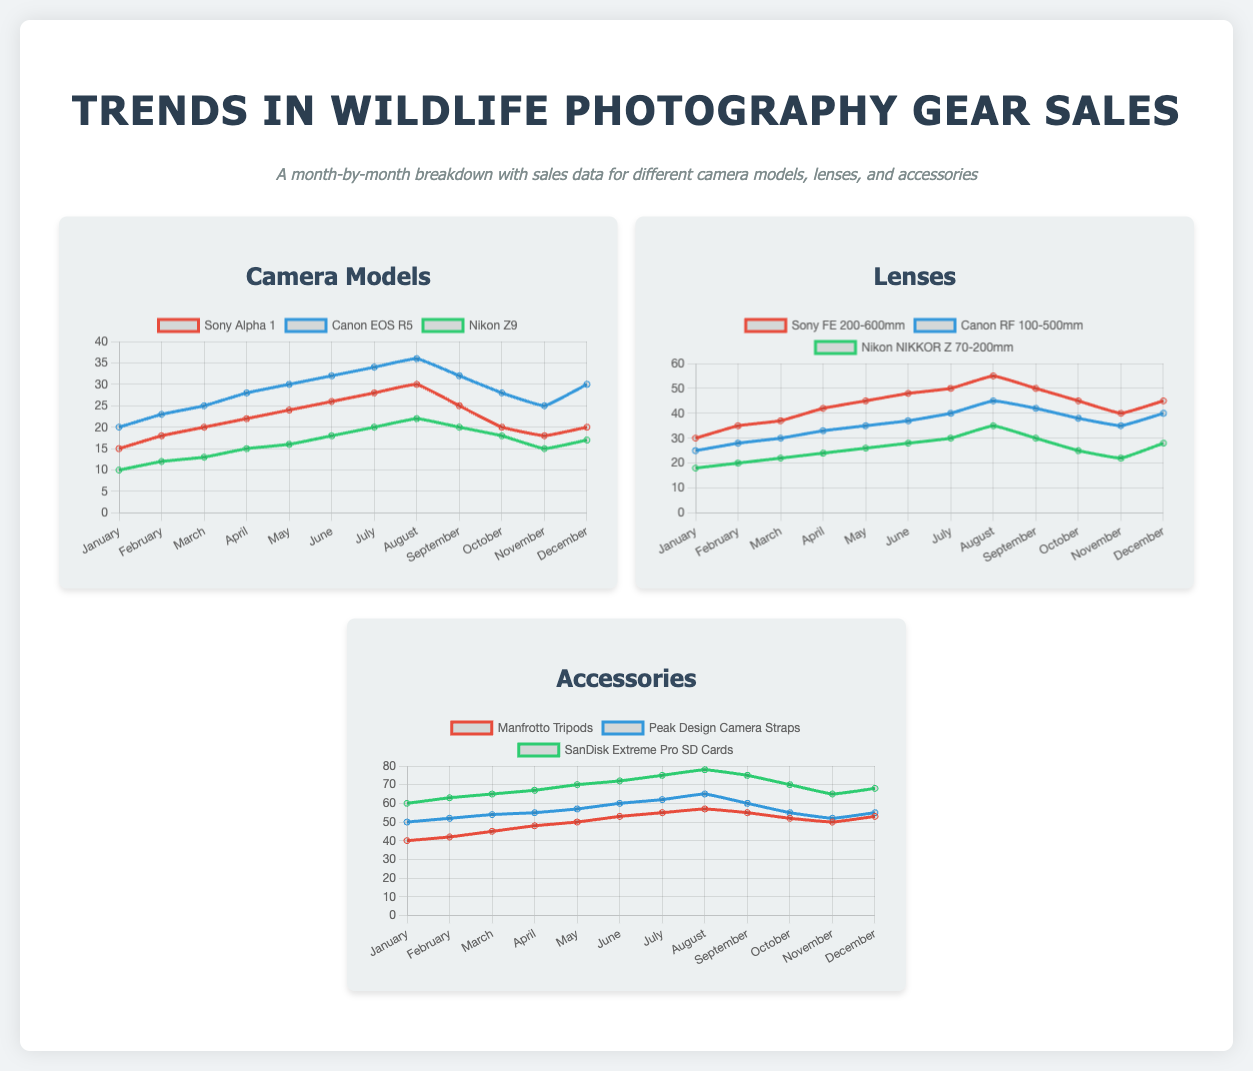What was the highest sales month for Sony Alpha 1? The highest sales month for Sony Alpha 1 is indicated by the peak in the chart, which is 30 in August.
Answer: 30 Which lens had the lowest sales in December? The lowest sales in December for lenses is shown in the chart for Nikon NIKKOR Z 70-200mm, which had 28 sales.
Answer: 28 What was the sales trend for Canon EOS R5 in March? The sales trend for Canon EOS R5 in March shows 25 units sold, as depicted in the chart.
Answer: 25 Which accessory had the highest sales for the year? The highest sales for accessories is illustrated for SanDisk Extreme Pro SD Cards, which had a maximum of 78 sales in August.
Answer: 78 Which camera model had sales of 20 units in November? The camera model with sales of 20 units in November is Sony Alpha 1, as shown in the sales data.
Answer: Sony Alpha 1 What is the overall sales trend for Manfrotto Tripods throughout the year? The overall sales trend for Manfrotto Tripods increases steadily with a peak of 57 sales in August and a slight drop towards the end.
Answer: Increase then slight drop How many different camera models were tracked in the sales data? The number of different camera models tracked in the sales data is indicated by three models listed in the chart.
Answer: Three Which accessory consistently sold above 60 units in the initial months? The accessory that consistently sold above 60 units in the initial months is SanDisk Extreme Pro SD Cards, based on the chart readings.
Answer: SanDisk Extreme Pro SD Cards 